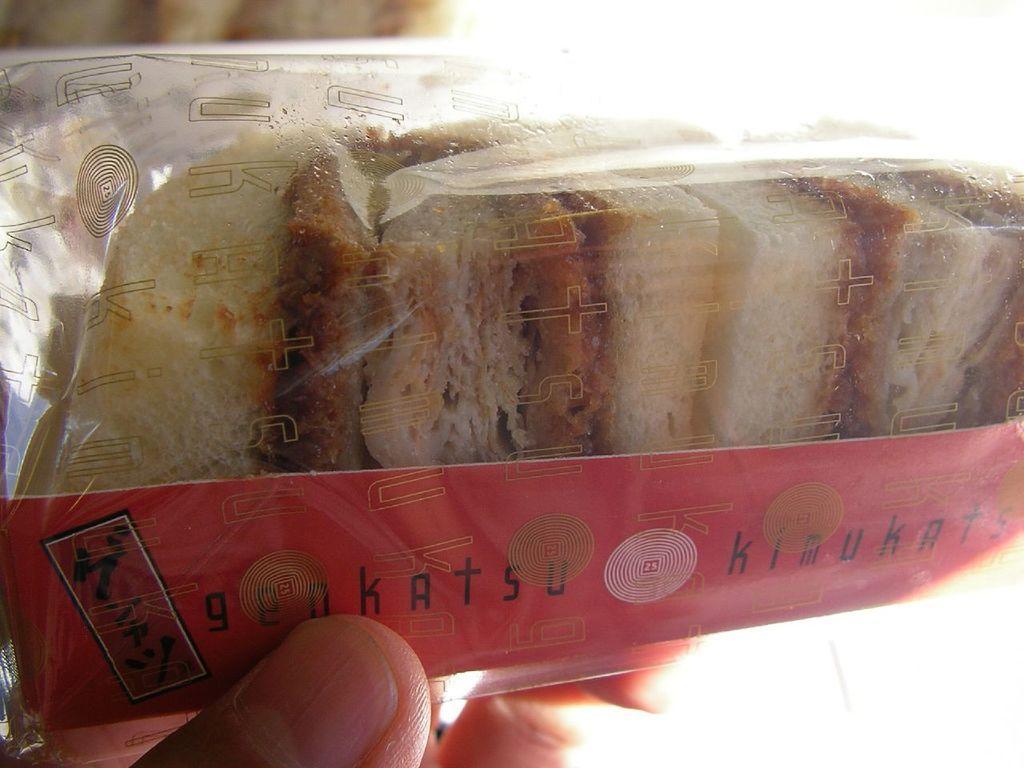Could you give a brief overview of what you see in this image? In the center of the image we can see fingers of a person holding a plastic packet. In the packet, we can see some food items and one small card with some text. And we can see some text on the plastic packet. In the background, we can see it is blurred. 